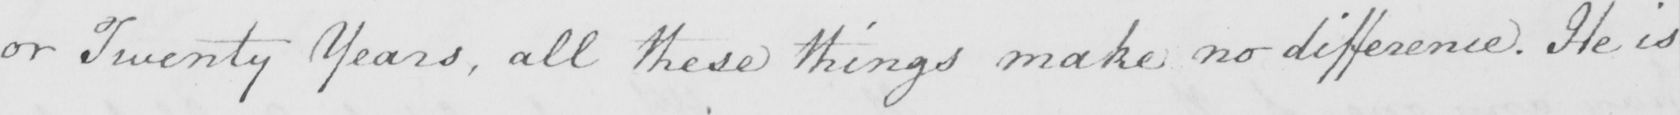Can you read and transcribe this handwriting? or Twenty Years , all these things make no difference . He is 